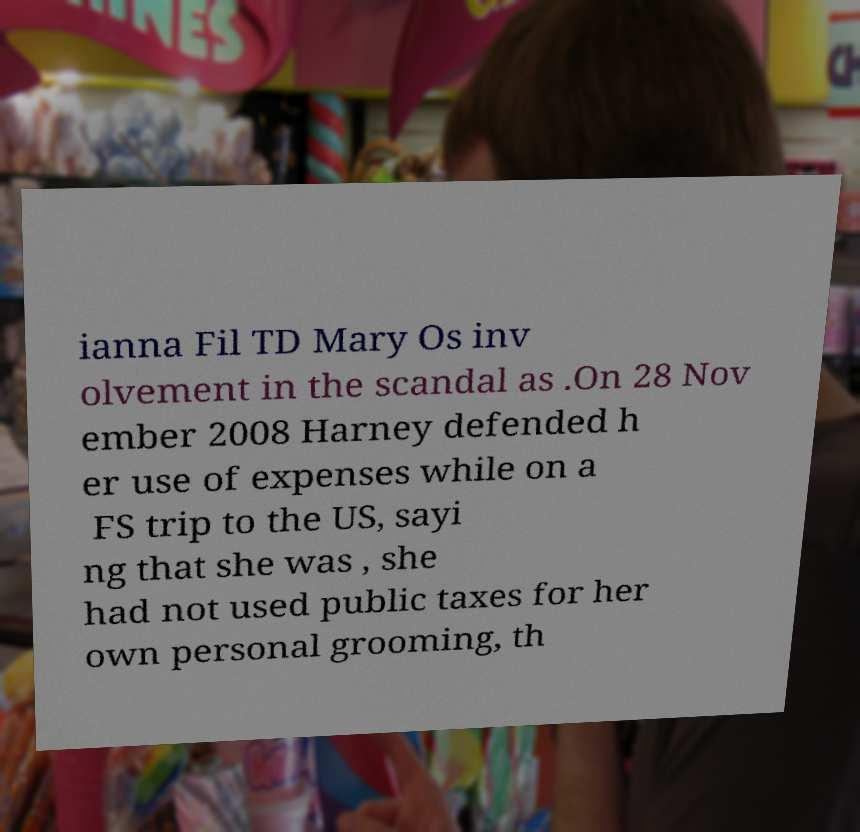Can you read and provide the text displayed in the image?This photo seems to have some interesting text. Can you extract and type it out for me? ianna Fil TD Mary Os inv olvement in the scandal as .On 28 Nov ember 2008 Harney defended h er use of expenses while on a FS trip to the US, sayi ng that she was , she had not used public taxes for her own personal grooming, th 